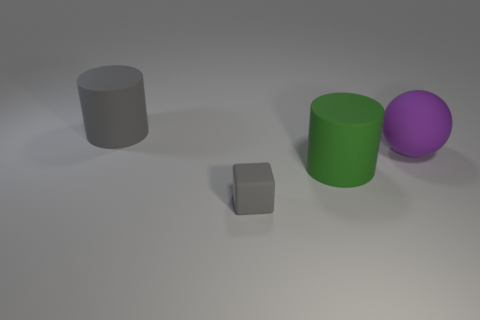Add 4 brown things. How many objects exist? 8 Subtract all cubes. How many objects are left? 3 Add 4 big purple things. How many big purple things are left? 5 Add 1 large gray cubes. How many large gray cubes exist? 1 Subtract 0 yellow cylinders. How many objects are left? 4 Subtract all small gray rubber objects. Subtract all gray matte blocks. How many objects are left? 2 